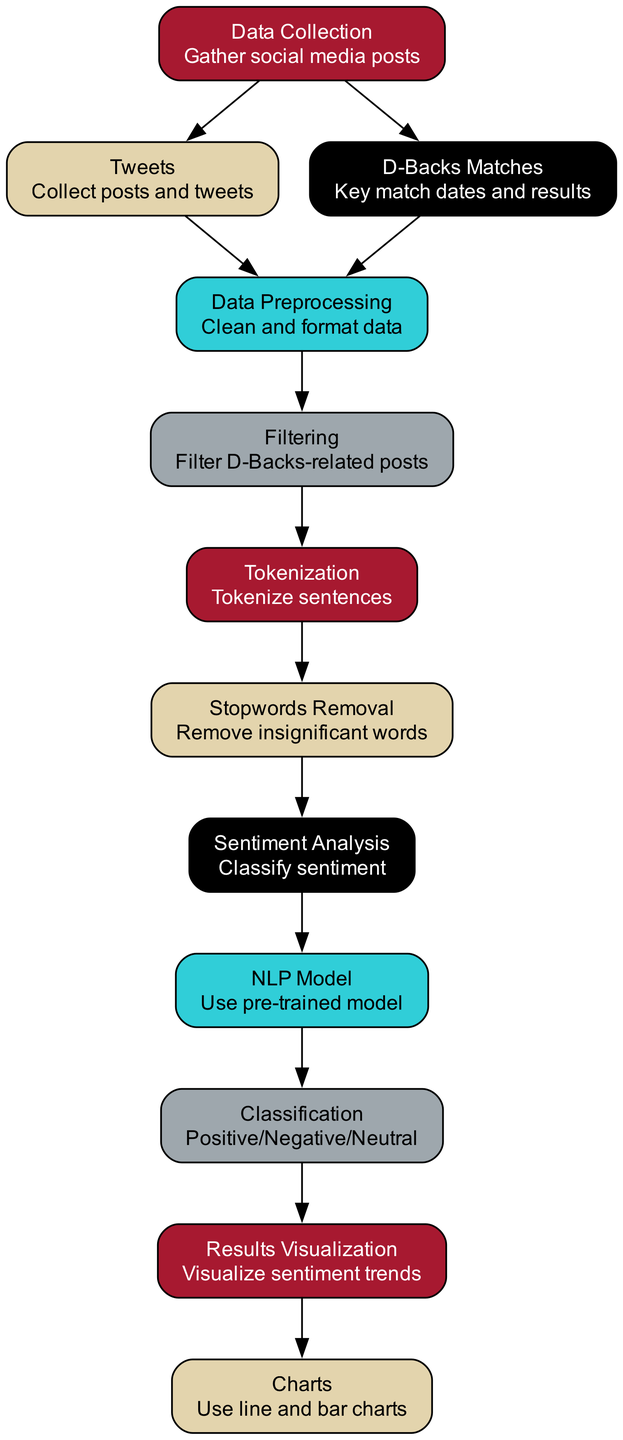What is the first step in the process? The first step is "Data Collection", which gathers social media posts. This is clearly indicated as the starting node in the diagram.
Answer: Data Collection How many nodes are in the diagram? There are 12 nodes in the diagram, each representing a unique step or component in the sentiment analysis process. This can be counted from the nodes section of the diagram.
Answer: 12 What does the "Sentiment Analysis" node lead to? The "Sentiment Analysis" node leads to the "NLP Model" node, indicating that the analysis phase requires a natural language processing model for classifying sentiments.
Answer: NLP Model Which nodes connect to "Data Preprocessing"? "Tweets" and "D-Backs Matches" connect to "Data Preprocessing", showing that both the collected posts and the match data are used for this crucial cleaning and formatting stage.
Answer: Tweets and D-Backs Matches What is the classification result of the "NLP Model"? The classification result is "Positive/Negative/Neutral", which shows the model categorizes sentiments into these three distinct classes.
Answer: Positive/Negative/Neutral How does data flow from "Results Visualization" to "Charts"? "Results Visualization" connects directly to "Charts", indicating that the visual representation of sentiment trends is created using charts as the final output of the analysis process.
Answer: Charts Which step involves tokenizing sentences? The step that involves tokenizing sentences is "Tokenization." This step occurs after filtering and is an essential part of breaking down the text for further analysis.
Answer: Tokenization What is removed during the "Stopwords Removal" step? Insignificant words are removed during this step, which helps refine the data by filtering out common words that may not add value to the sentiment analysis.
Answer: Insignificant words What is the purpose of the "Data Collection" node? The purpose is to gather social media posts, which is the foundational stage for any analysis. This is made clear in the description of the node.
Answer: Gather social media posts 